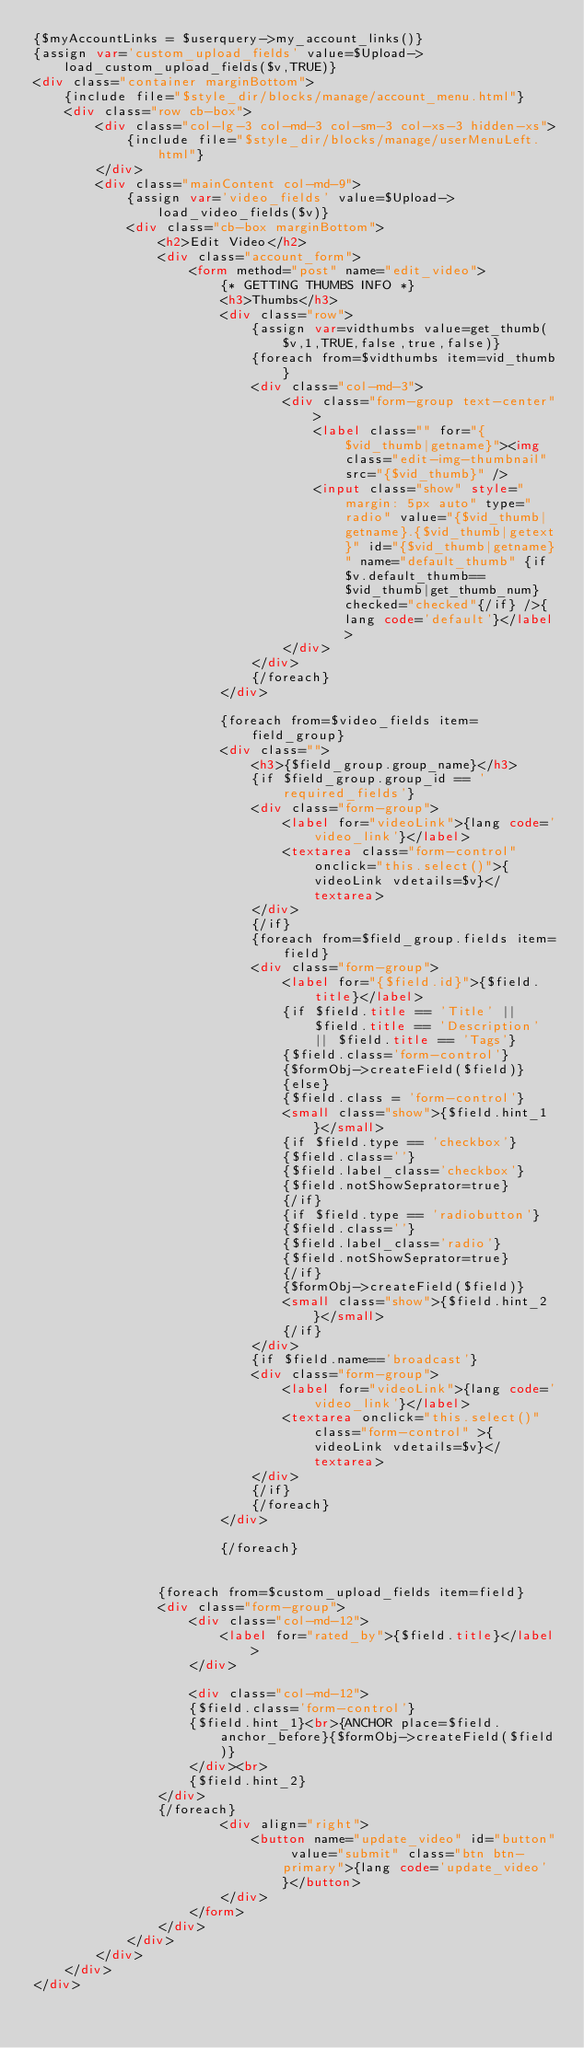Convert code to text. <code><loc_0><loc_0><loc_500><loc_500><_HTML_>{$myAccountLinks = $userquery->my_account_links()}
{assign var='custom_upload_fields' value=$Upload->load_custom_upload_fields($v,TRUE)}
<div class="container marginBottom">
    {include file="$style_dir/blocks/manage/account_menu.html"}
    <div class="row cb-box">
        <div class="col-lg-3 col-md-3 col-sm-3 col-xs-3 hidden-xs">
            {include file="$style_dir/blocks/manage/userMenuLeft.html"}
        </div>
        <div class="mainContent col-md-9">
            {assign var='video_fields' value=$Upload->load_video_fields($v)}
            <div class="cb-box marginBottom">
                <h2>Edit Video</h2>
                <div class="account_form">
                    <form method="post" name="edit_video">
                        {* GETTING THUMBS INFO *}
                        <h3>Thumbs</h3>
                        <div class="row">
                            {assign var=vidthumbs value=get_thumb($v,1,TRUE,false,true,false)}
                            {foreach from=$vidthumbs item=vid_thumb}
                            <div class="col-md-3">
                                <div class="form-group text-center">
                                    <label class="" for="{$vid_thumb|getname}"><img class="edit-img-thumbnail" src="{$vid_thumb}" />
                                    <input class="show" style="margin: 5px auto" type="radio" value="{$vid_thumb|getname}.{$vid_thumb|getext}" id="{$vid_thumb|getname}" name="default_thumb" {if $v.default_thumb==$vid_thumb|get_thumb_num} checked="checked"{/if} />{lang code='default'}</label>
                                </div>
                            </div>
                            {/foreach}
                        </div>

                        {foreach from=$video_fields item=field_group}
                        <div class="">
                            <h3>{$field_group.group_name}</h3>
                            {if $field_group.group_id == 'required_fields'}
                            <div class="form-group">
                                <label for="videoLink">{lang code='video_link'}</label>
                                <textarea class="form-control" onclick="this.select()">{videoLink vdetails=$v}</textarea>
                            </div>
                            {/if}
                            {foreach from=$field_group.fields item=field}
                            <div class="form-group">
                                <label for="{$field.id}">{$field.title}</label>
                                {if $field.title == 'Title' || $field.title == 'Description' || $field.title == 'Tags'}
                                {$field.class='form-control'}
                                {$formObj->createField($field)}
                                {else}
                                {$field.class = 'form-control'}
                                <small class="show">{$field.hint_1}</small>
                                {if $field.type == 'checkbox'}
                                {$field.class=''}
                                {$field.label_class='checkbox'}
                                {$field.notShowSeprator=true}
                                {/if}
                                {if $field.type == 'radiobutton'}
                                {$field.class=''}
                                {$field.label_class='radio'}
                                {$field.notShowSeprator=true}
                                {/if}
                                {$formObj->createField($field)}
                                <small class="show">{$field.hint_2}</small>
                                {/if}
                            </div>
                            {if $field.name=='broadcast'}
                            <div class="form-group">
                                <label for="videoLink">{lang code='video_link'}</label>
                                <textarea onclick="this.select()" class="form-control" >{videoLink vdetails=$v}</textarea>
                            </div>
                            {/if}
                            {/foreach}
                        </div>

                        {/foreach}

 
                {foreach from=$custom_upload_fields item=field}
                <div class="form-group">
                    <div class="col-md-12">
                        <label for="rated_by">{$field.title}</label>
                    </div>

                    <div class="col-md-12">
                    {$field.class='form-control'}
                    {$field.hint_1}<br>{ANCHOR place=$field.anchor_before}{$formObj->createField($field)}
                    </div><br>
                    {$field.hint_2}
                </div>
                {/foreach}
                        <div align="right">
                            <button name="update_video" id="button" value="submit" class="btn btn-primary">{lang code='update_video'}</button>
                        </div>
                    </form>
                </div>
            </div>
        </div>
    </div>
</div>




</code> 